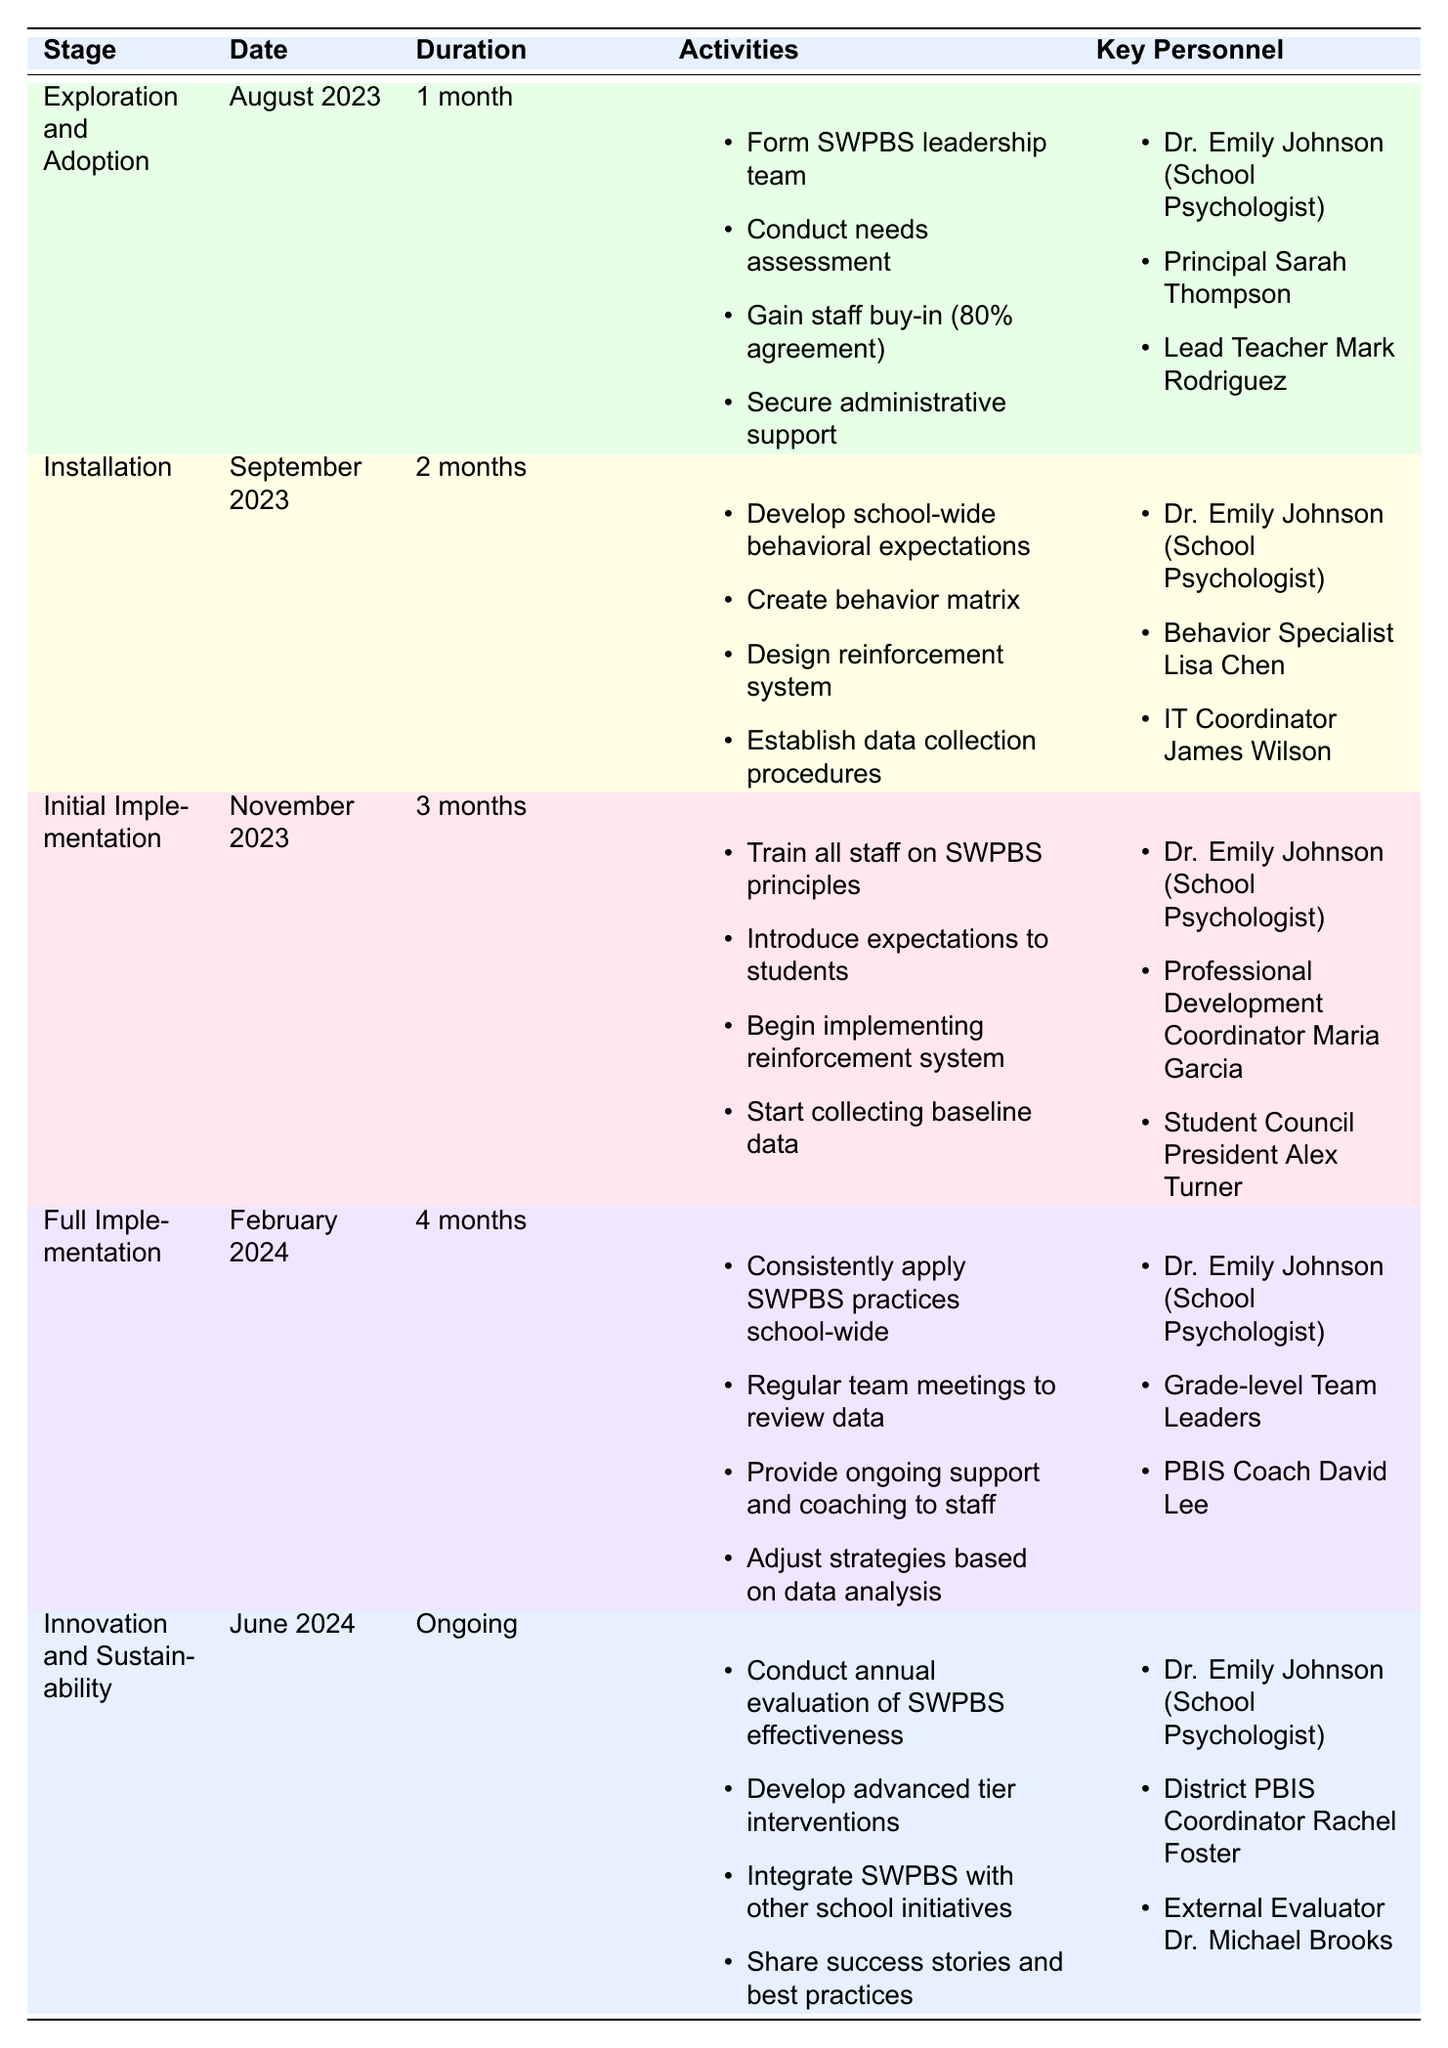What are the activities involved in the Initial Implementation stage? By locating the "Initial Implementation" row in the table, I found that the activities listed under this stage include training all staff on SWPBS principles, introducing expectations to students, beginning the implementation of the reinforcement system, and starting to collect baseline data.
Answer: Train all staff on SWPBS principles, introduce expectations to students, begin implementing reinforcement system, start collecting baseline data Who are the key personnel involved in the Full Implementation stage? The "Full Implementation" row indicates that the key personnel for this stage are Dr. Emily Johnson (School Psychologist), Grade-level Team Leaders, and PBIS Coach David Lee.
Answer: Dr. Emily Johnson, Grade-level Team Leaders, PBIS Coach David Lee True or False: The duration of the Innovation and Sustainability stage is ongoing. By referring to the "Innovation and Sustainability" row, I can see that its duration is indicated as "Ongoing," which supports that the statement is true.
Answer: True How many months does the Installation stage last? The "Installation" row states that its duration is 2 months, which is directly mentioned in the table.
Answer: 2 months What is the total duration of the stages from Exploration and Adoption to Full Implementation? To calculate the total duration, I sum the durations: Exploration and Adoption (1 month) + Installation (2 months) + Initial Implementation (3 months) + Full Implementation (4 months) = 1 + 2 + 3 + 4 = 10 months.
Answer: 10 months What activities are necessary for the Installation stage? Looking at the "Installation" row, I see that it involves developing school-wide behavioral expectations, creating a behavior matrix, designing a reinforcement system, and establishing data collection procedures.
Answer: Develop behavioral expectations, create behavior matrix, design reinforcement system, establish data collection procedures Who among the key personnel is involved in the Exploration and Adoption stage? The "Exploration and Adoption" row indicates that the key personnel are Dr. Emily Johnson (School Psychologist), Principal Sarah Thompson, and Lead Teacher Mark Rodriguez.
Answer: Dr. Emily Johnson, Principal Sarah Thompson, Lead Teacher Mark Rodriguez Which stage has the longest duration, and what is that duration? Comparing the durations listed in the table, Full Implementation has the longest duration of 4 months, making it the stage with the most time allocated.
Answer: Full Implementation, 4 months Is it true that Dr. Emily Johnson is involved in every stage listed in the table? By checking the rows for each stage, I confirm that Dr. Emily Johnson appears as key personnel in all the stages: Exploration and Adoption, Installation, Initial Implementation, Full Implementation, and Innovation and Sustainability. Therefore, the statement is true.
Answer: True 